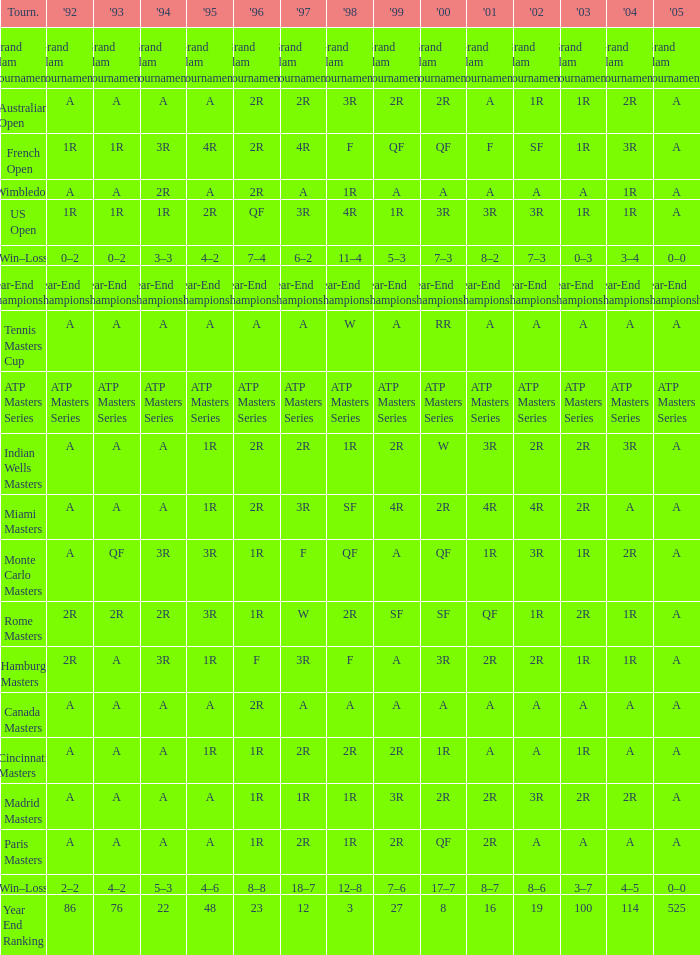What is 2005, when 1998 is "F", and when 2002 is "2R"? A. 